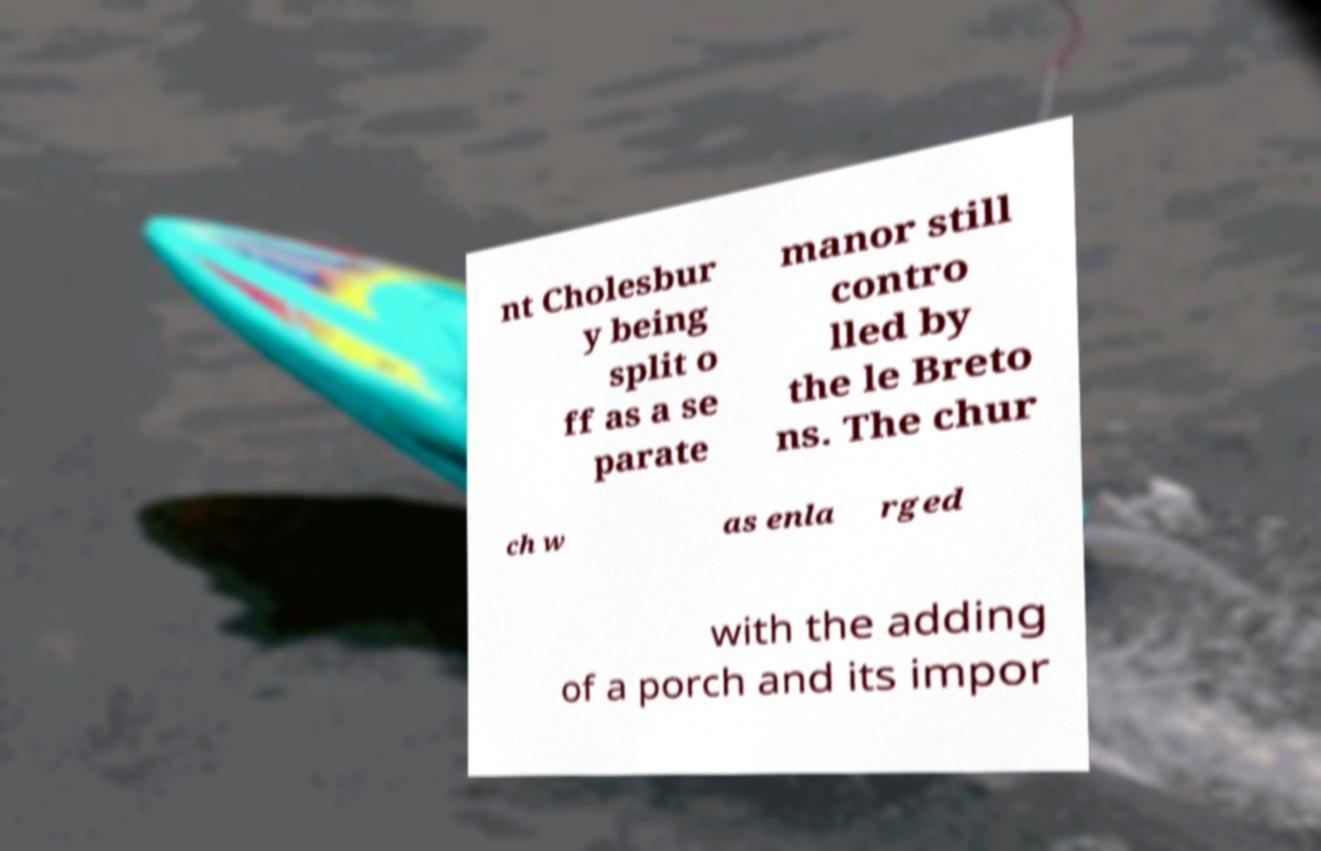Could you assist in decoding the text presented in this image and type it out clearly? nt Cholesbur y being split o ff as a se parate manor still contro lled by the le Breto ns. The chur ch w as enla rged with the adding of a porch and its impor 